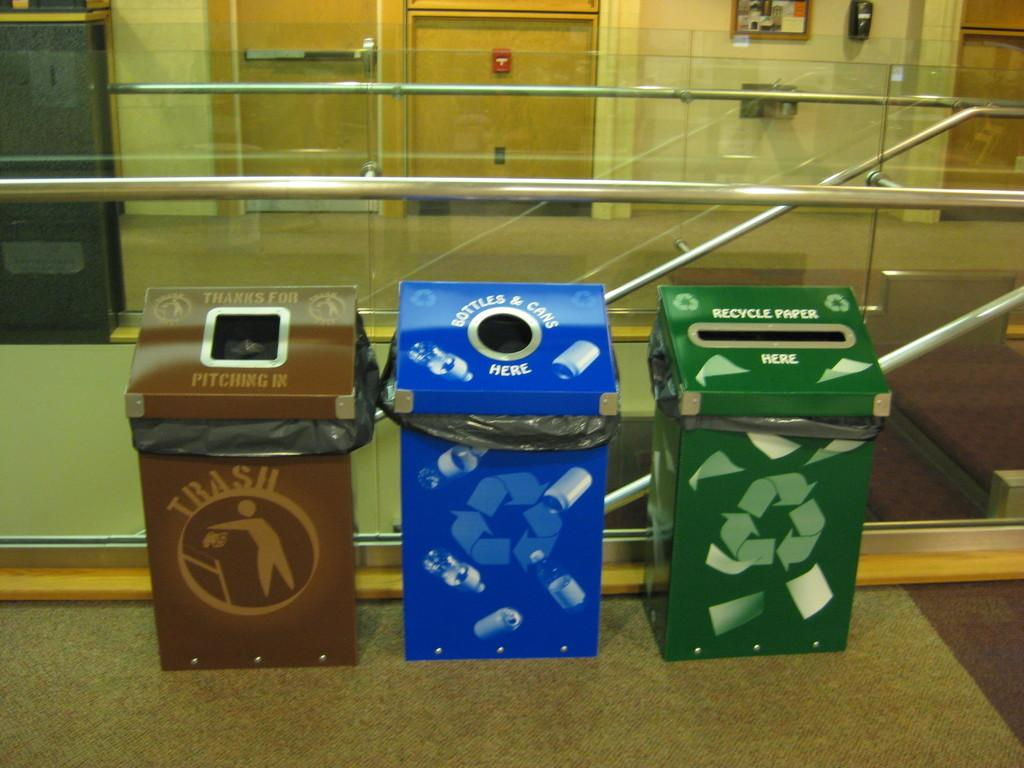<image>
Summarize the visual content of the image. three bins for different recycling are set up side by side 